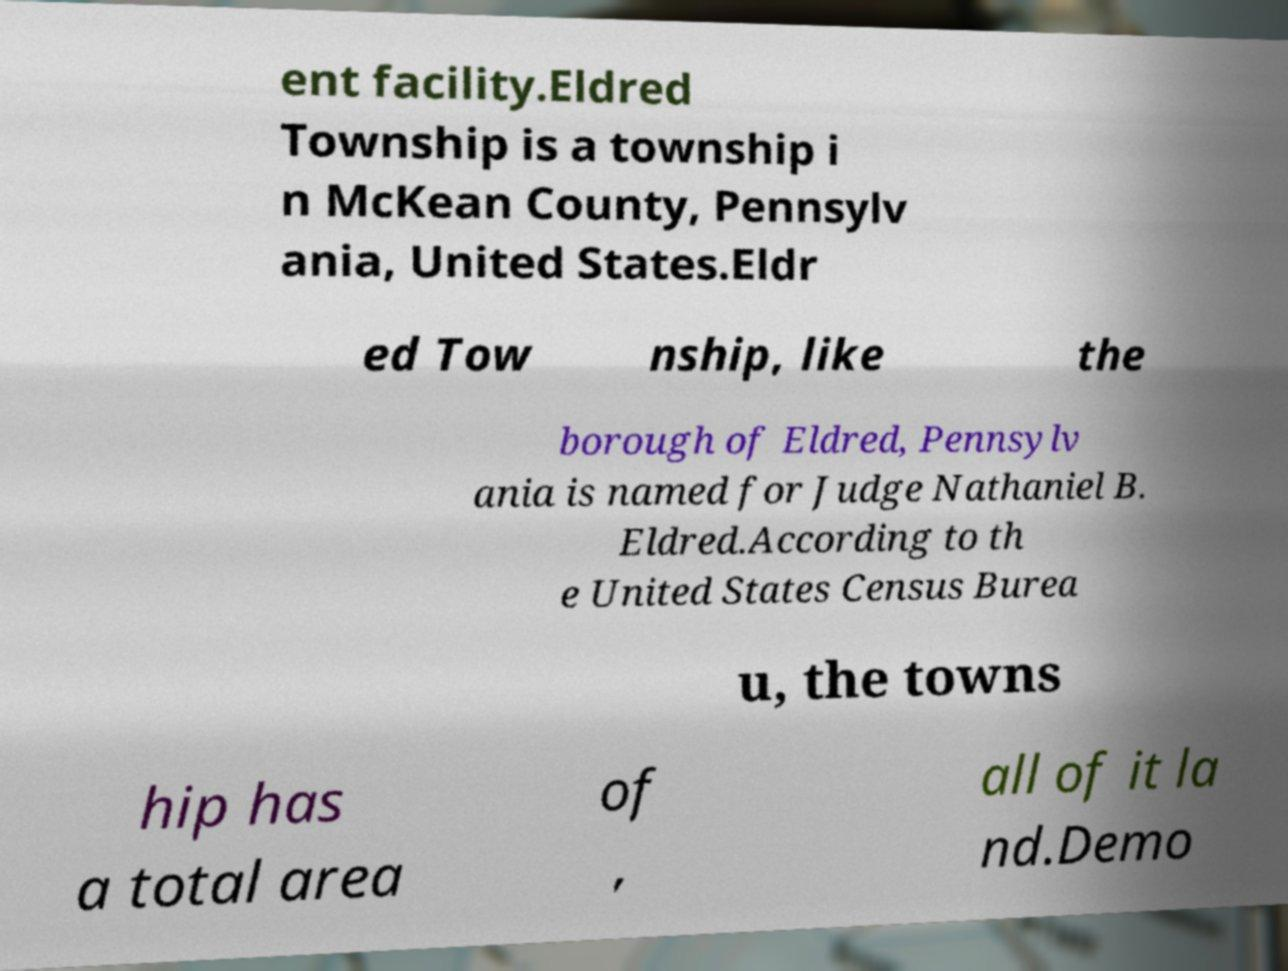For documentation purposes, I need the text within this image transcribed. Could you provide that? ent facility.Eldred Township is a township i n McKean County, Pennsylv ania, United States.Eldr ed Tow nship, like the borough of Eldred, Pennsylv ania is named for Judge Nathaniel B. Eldred.According to th e United States Census Burea u, the towns hip has a total area of , all of it la nd.Demo 